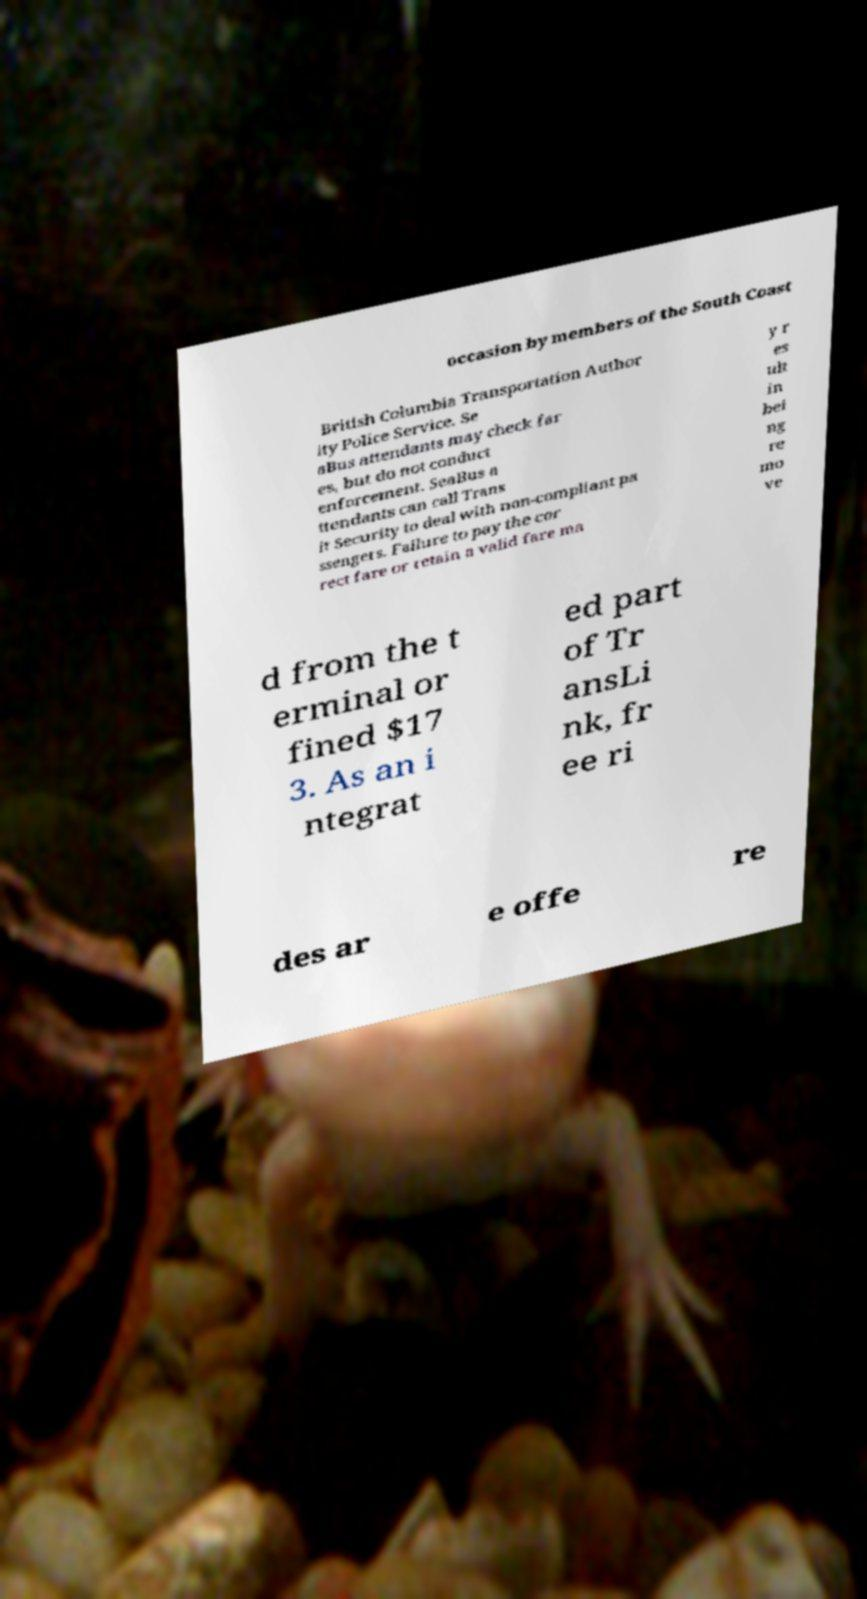For documentation purposes, I need the text within this image transcribed. Could you provide that? occasion by members of the South Coast British Columbia Transportation Author ity Police Service. Se aBus attendants may check far es, but do not conduct enforcement. SeaBus a ttendants can call Trans it Security to deal with non-compliant pa ssengers. Failure to pay the cor rect fare or retain a valid fare ma y r es ult in bei ng re mo ve d from the t erminal or fined $17 3. As an i ntegrat ed part of Tr ansLi nk, fr ee ri des ar e offe re 